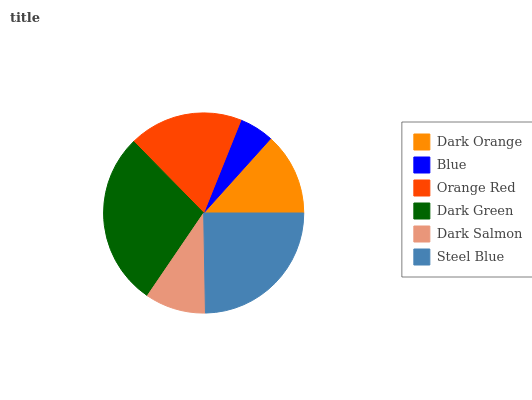Is Blue the minimum?
Answer yes or no. Yes. Is Dark Green the maximum?
Answer yes or no. Yes. Is Orange Red the minimum?
Answer yes or no. No. Is Orange Red the maximum?
Answer yes or no. No. Is Orange Red greater than Blue?
Answer yes or no. Yes. Is Blue less than Orange Red?
Answer yes or no. Yes. Is Blue greater than Orange Red?
Answer yes or no. No. Is Orange Red less than Blue?
Answer yes or no. No. Is Orange Red the high median?
Answer yes or no. Yes. Is Dark Orange the low median?
Answer yes or no. Yes. Is Dark Orange the high median?
Answer yes or no. No. Is Blue the low median?
Answer yes or no. No. 